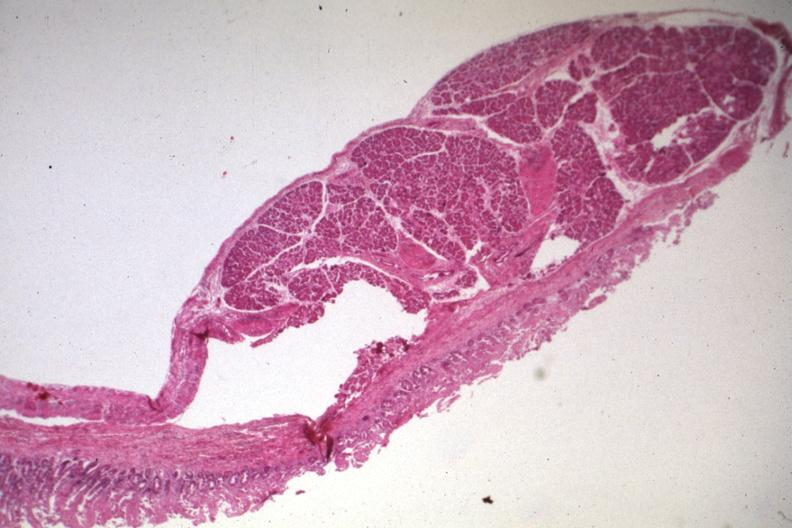s digital infarcts bacterial endocarditis present?
Answer the question using a single word or phrase. No 